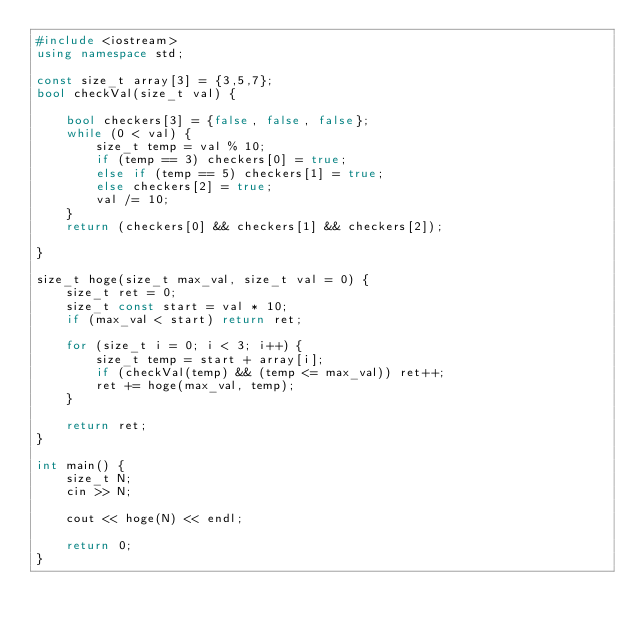<code> <loc_0><loc_0><loc_500><loc_500><_C++_>#include <iostream>
using namespace std;

const size_t array[3] = {3,5,7};
bool checkVal(size_t val) {

    bool checkers[3] = {false, false, false};
    while (0 < val) {
        size_t temp = val % 10;
        if (temp == 3) checkers[0] = true;
        else if (temp == 5) checkers[1] = true;
        else checkers[2] = true;
        val /= 10;
    }
    return (checkers[0] && checkers[1] && checkers[2]);

}

size_t hoge(size_t max_val, size_t val = 0) {
    size_t ret = 0;
    size_t const start = val * 10;
    if (max_val < start) return ret;

    for (size_t i = 0; i < 3; i++) {
        size_t temp = start + array[i];
        if (checkVal(temp) && (temp <= max_val)) ret++;
        ret += hoge(max_val, temp); 
    }
    
    return ret;
}

int main() {
    size_t N;
    cin >> N;

    cout << hoge(N) << endl;

    return 0;
}

</code> 